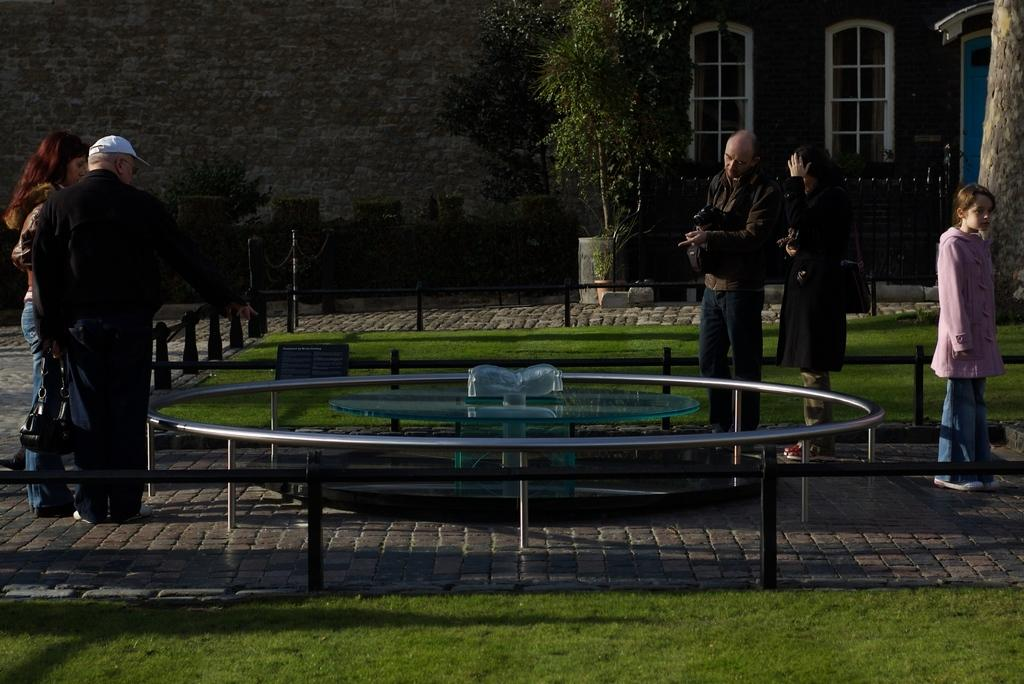What are the people in the image doing? The persons standing on the floor in the image are likely observing or interacting with the sculpture. What is surrounding the sculpture in the image? There are railings around the sculpture in the image. What type of natural environment is visible in the image? There is grass visible in the image. What type of signage is present in the image? There is an information board in the image. What type of barriers are present in the image? There are barrier poles in the image. What type of vegetation is present in the image? There are plants and bushes in the image. What type of man-made structures are visible in the image? There are buildings in the image. Can you describe the waves crashing on the shore in the image? There are no waves or shore visible in the image; it features a sculpture surrounded by railings, grass, and other vegetation. What type of stew is being served at the event in the image? There is no event or stew present in the image; it features a sculpture surrounded by railings, grass, and other vegetation. 